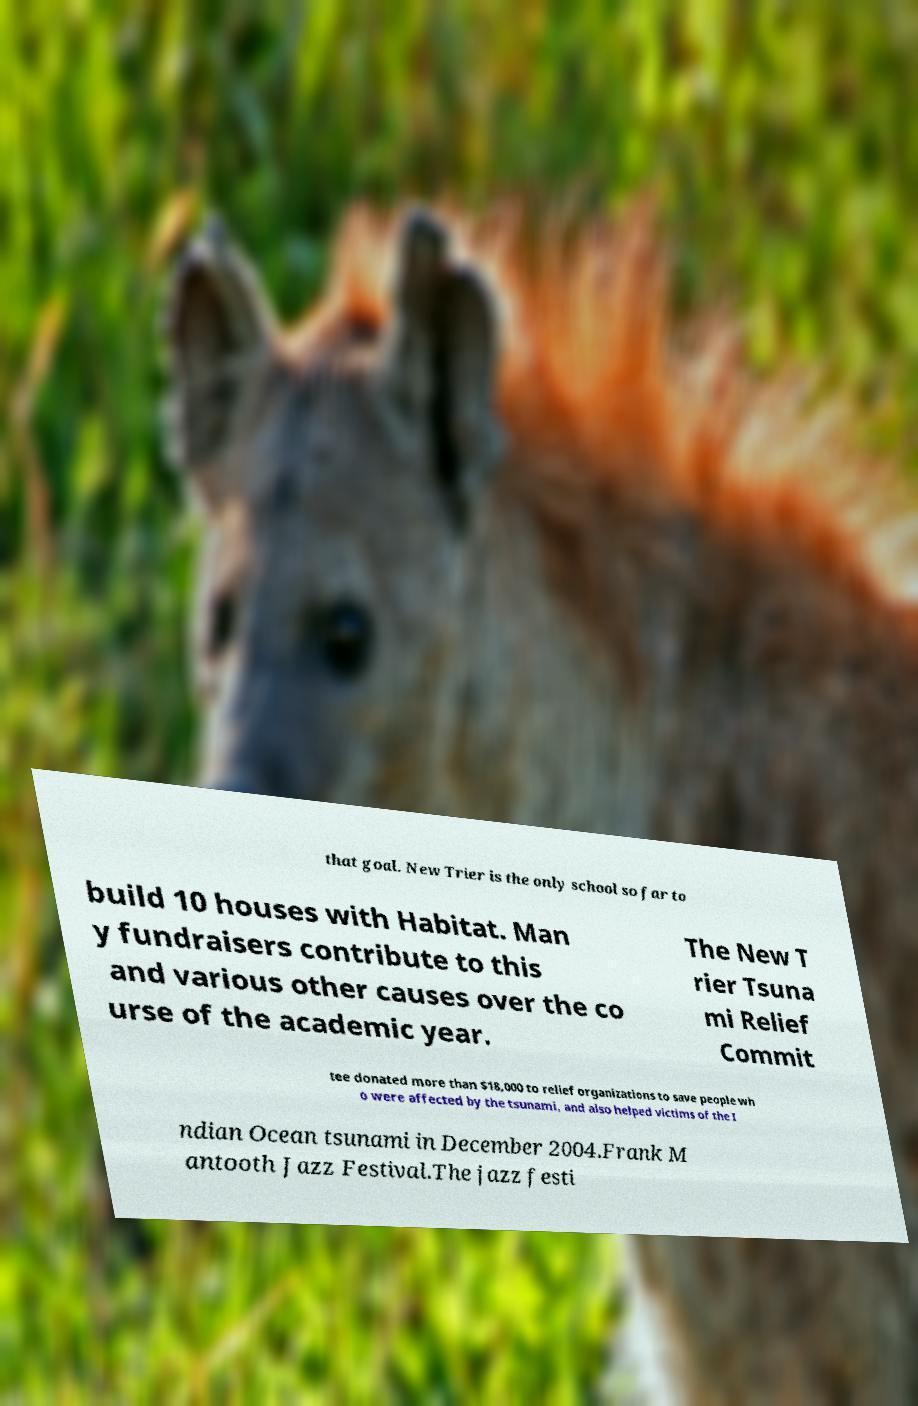There's text embedded in this image that I need extracted. Can you transcribe it verbatim? that goal. New Trier is the only school so far to build 10 houses with Habitat. Man y fundraisers contribute to this and various other causes over the co urse of the academic year. The New T rier Tsuna mi Relief Commit tee donated more than $18,000 to relief organizations to save people wh o were affected by the tsunami, and also helped victims of the I ndian Ocean tsunami in December 2004.Frank M antooth Jazz Festival.The jazz festi 